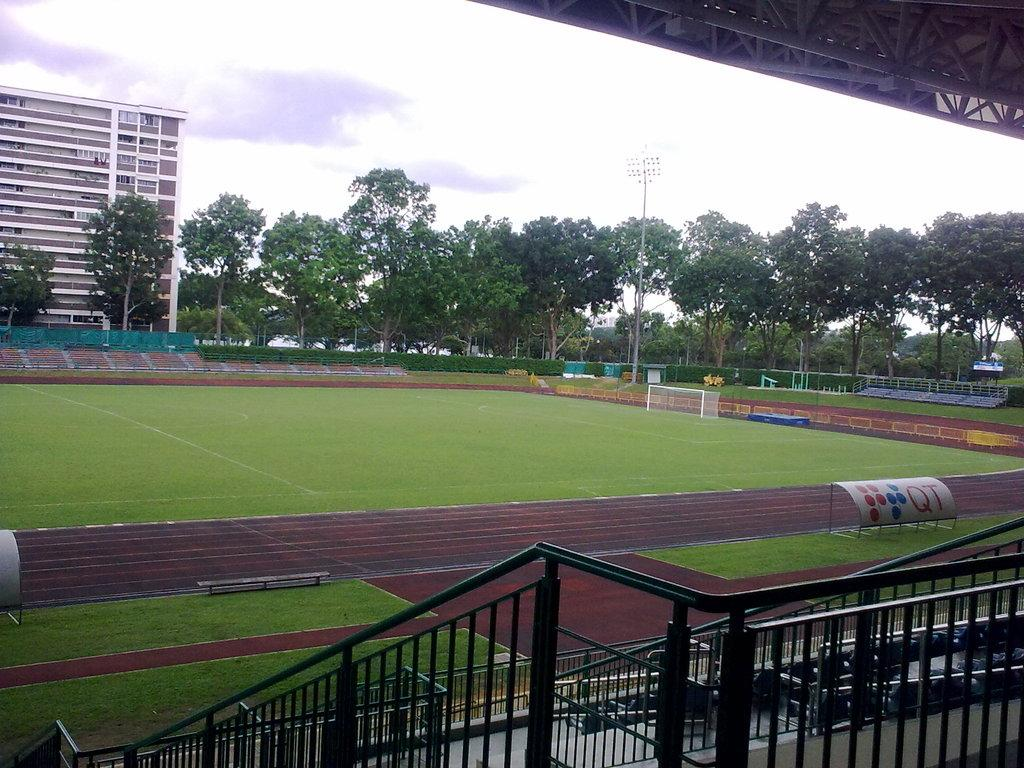What is located at the bottom of the image? There are fences at the bottom of the image. What can be seen in the background of the image? The sky, clouds, trees, at least one building, grass, a pole, and a goal post are visible in the background of the image. How many objects can be identified in the background of the image? There are at least ten objects visible in the background of the image. What type of cream is being spread on the hill in the image? There is no hill or cream present in the image. What is being served for lunch in the image? The image does not depict any food or meal, so it cannot be determined what is being served for lunch. 